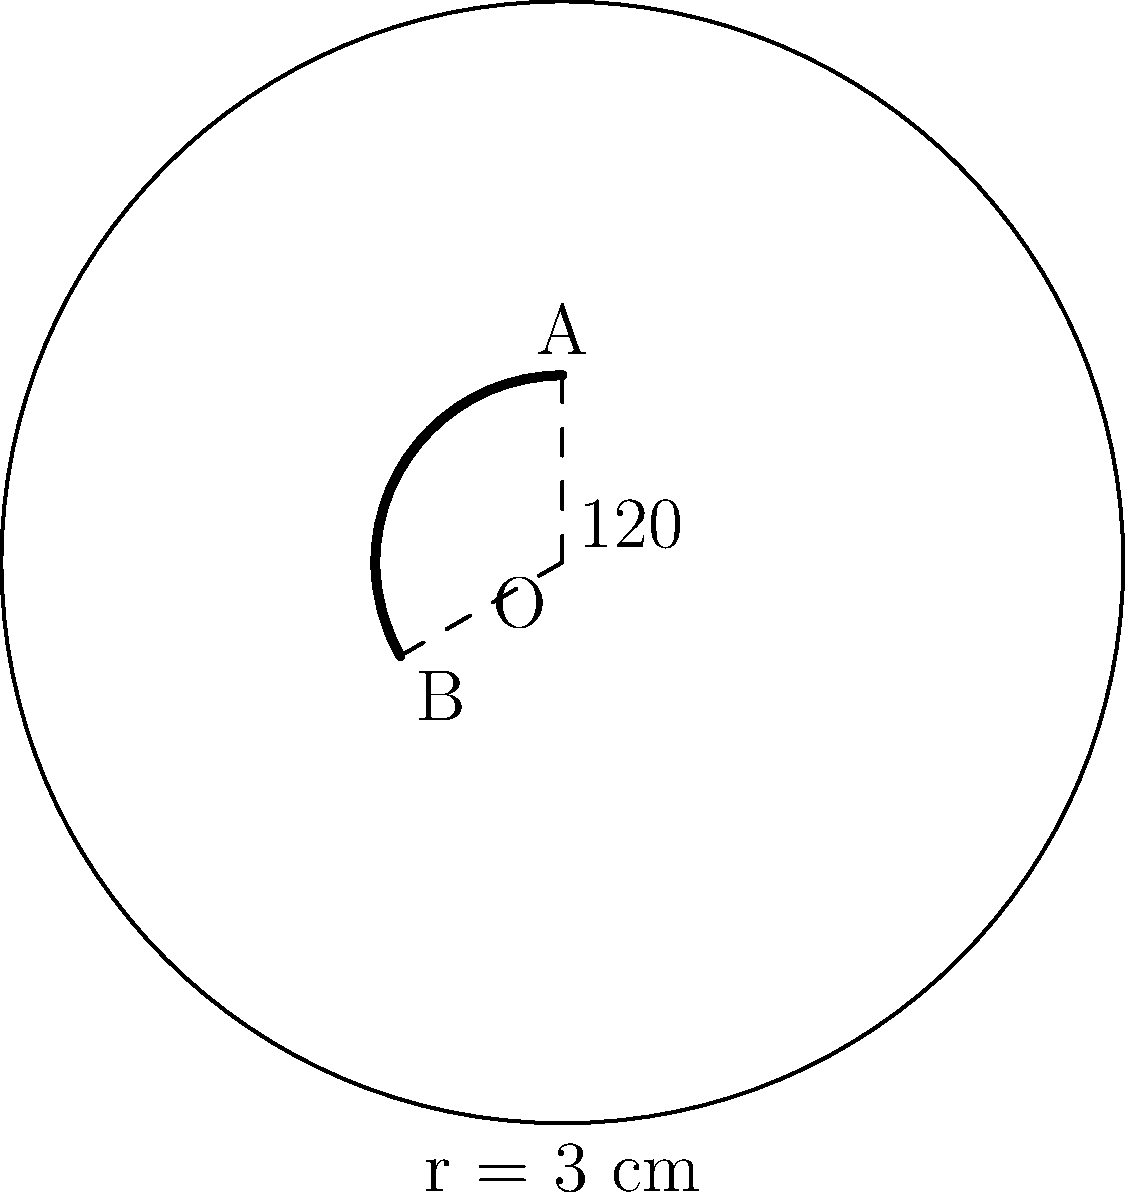In preparation for Halloween, you're designing an origami witch's hat. The brim of the hat is represented by an arc on a circle with radius 3 cm. If the central angle of this arc is 120°, what is the length of the arc forming the hat's brim? To find the length of the arc, we'll use the formula for arc length:

$$ \text{Arc Length} = \frac{\theta}{360°} \cdot 2\pi r $$

Where:
- $\theta$ is the central angle in degrees
- $r$ is the radius of the circle

Given:
- Radius $r = 3$ cm
- Central angle $\theta = 120°$

Step 1: Substitute the values into the formula:
$$ \text{Arc Length} = \frac{120°}{360°} \cdot 2\pi \cdot 3 $$

Step 2: Simplify the fraction:
$$ \text{Arc Length} = \frac{1}{3} \cdot 2\pi \cdot 3 $$

Step 3: Calculate:
$$ \text{Arc Length} = 2\pi \text{ cm} $$

Therefore, the length of the arc forming the witch's hat brim is $2\pi$ cm or approximately 6.28 cm.
Answer: $2\pi$ cm 